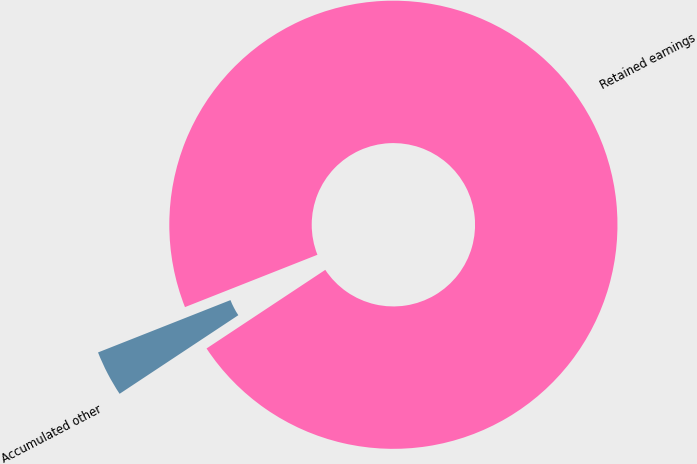<chart> <loc_0><loc_0><loc_500><loc_500><pie_chart><fcel>Retained earnings<fcel>Accumulated other<nl><fcel>96.68%<fcel>3.32%<nl></chart> 